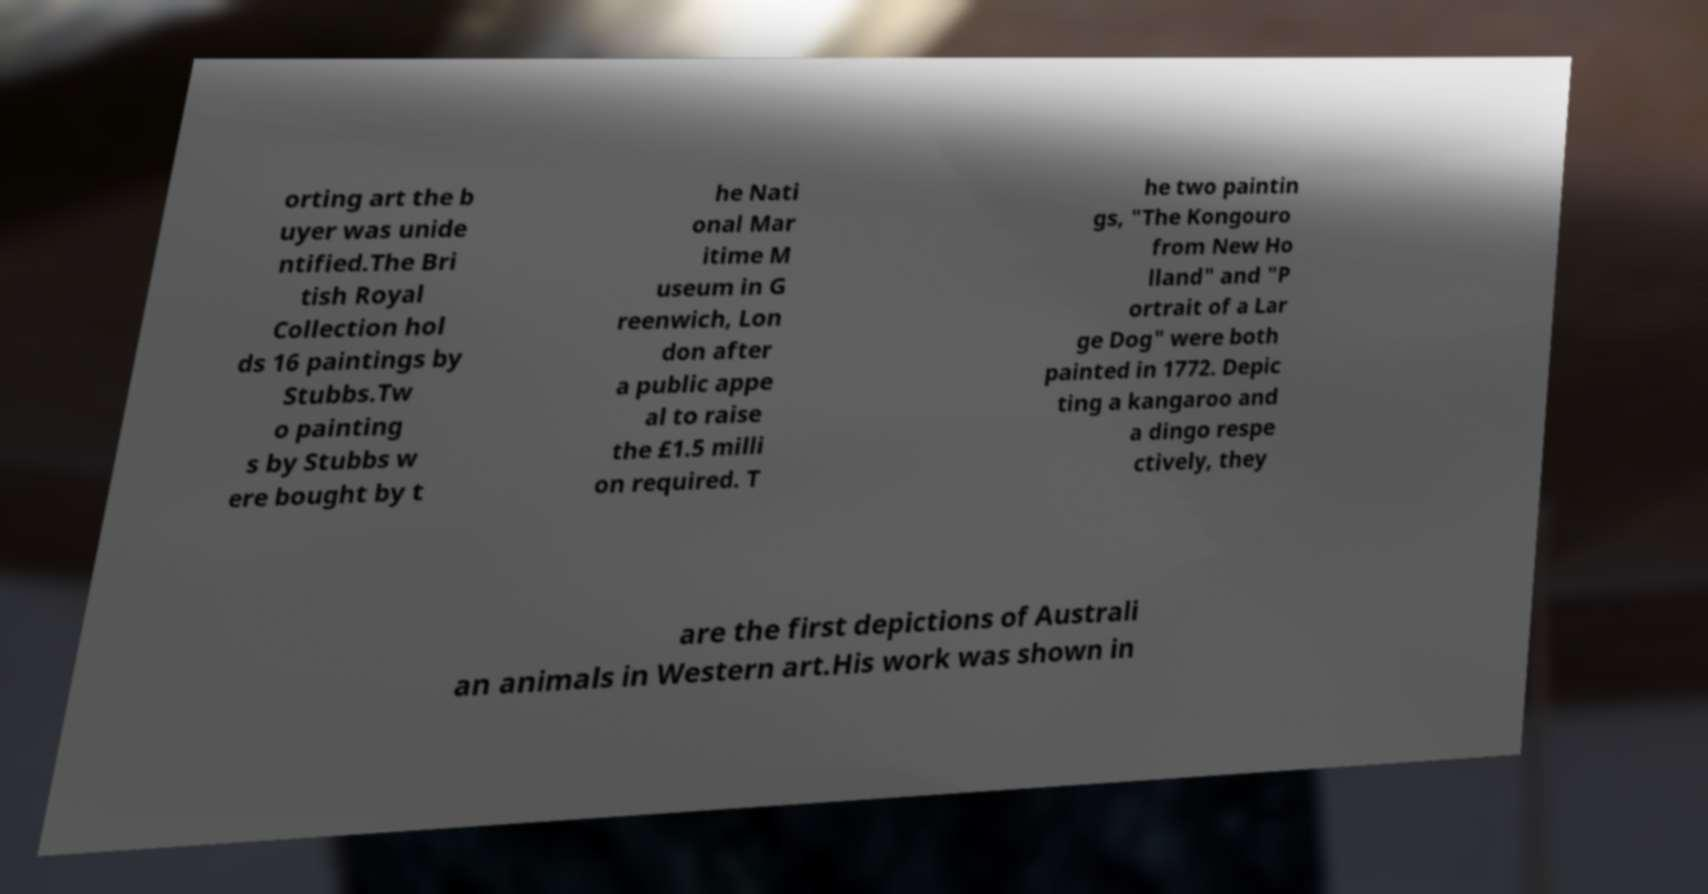There's text embedded in this image that I need extracted. Can you transcribe it verbatim? orting art the b uyer was unide ntified.The Bri tish Royal Collection hol ds 16 paintings by Stubbs.Tw o painting s by Stubbs w ere bought by t he Nati onal Mar itime M useum in G reenwich, Lon don after a public appe al to raise the £1.5 milli on required. T he two paintin gs, "The Kongouro from New Ho lland" and "P ortrait of a Lar ge Dog" were both painted in 1772. Depic ting a kangaroo and a dingo respe ctively, they are the first depictions of Australi an animals in Western art.His work was shown in 